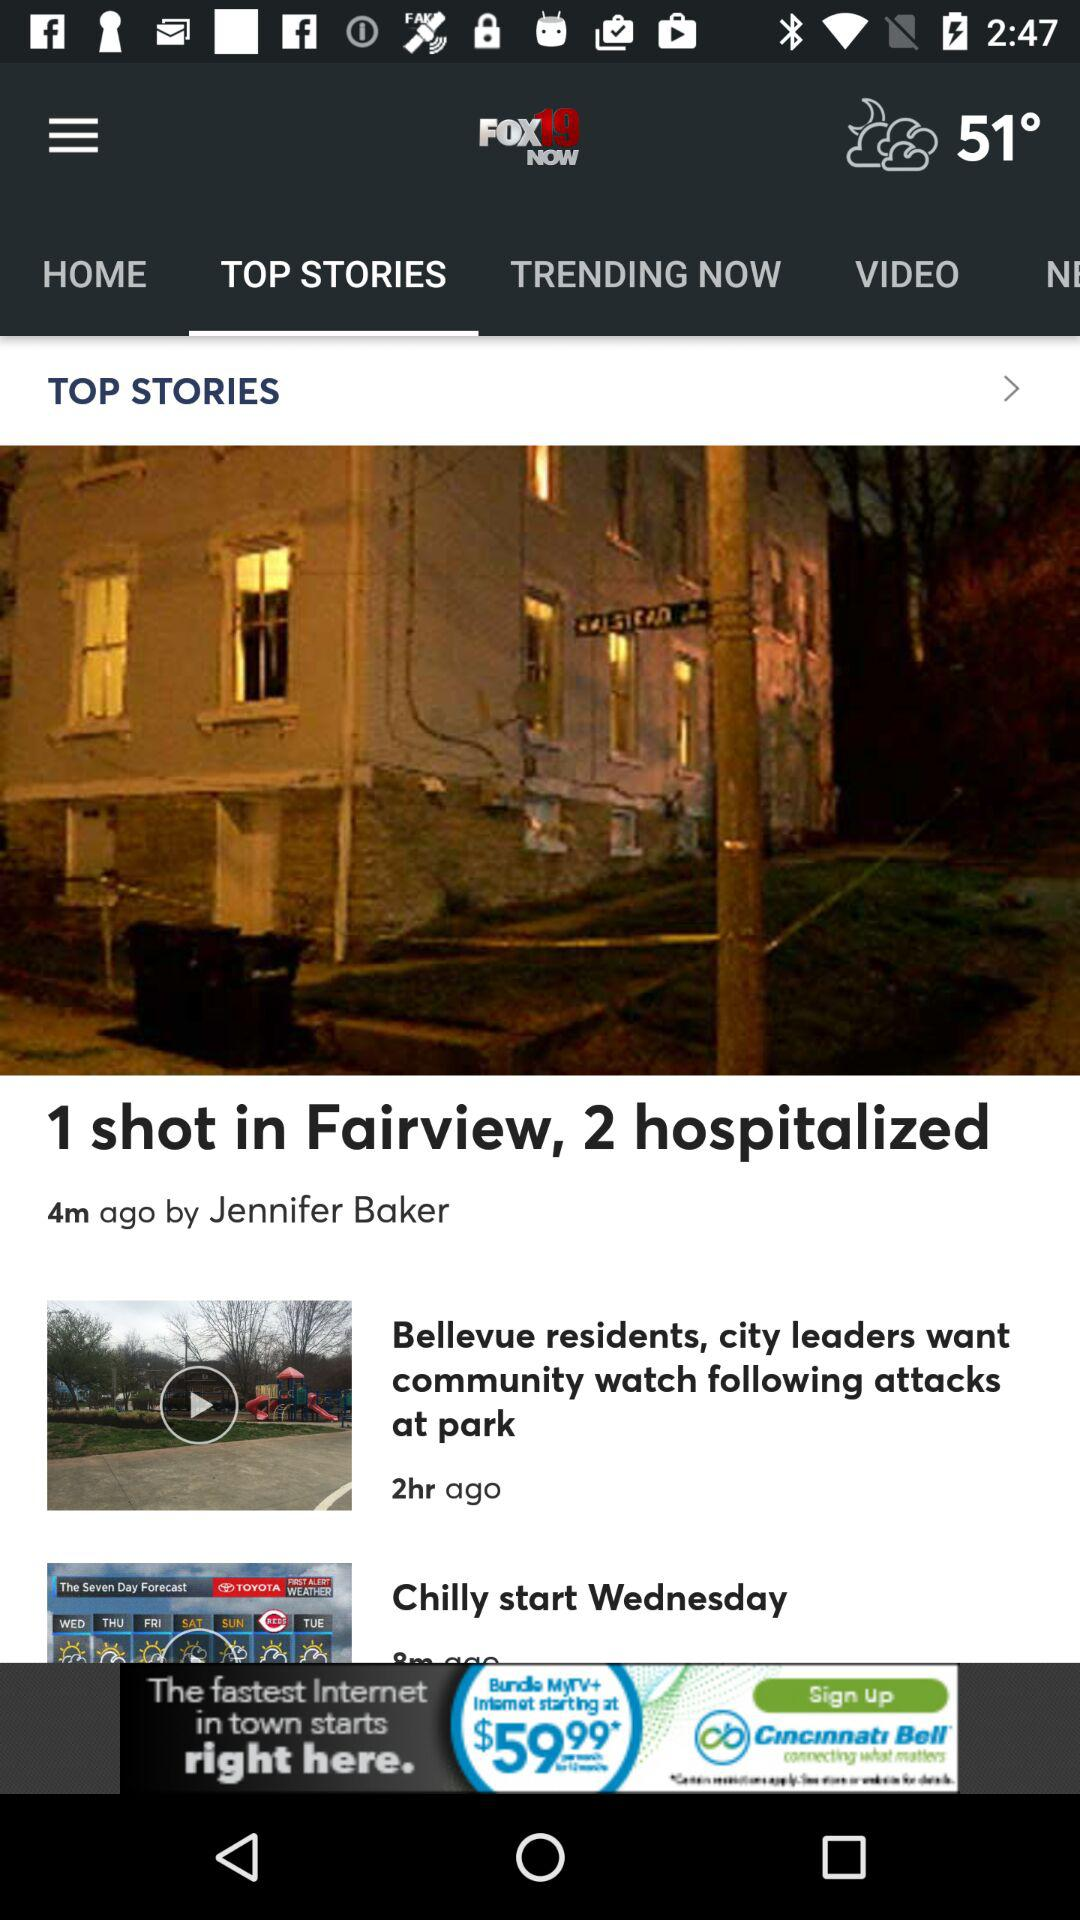How long ago was the "1 shot in Fairview, 2 hospitalized" post posted? The "1 shot in Fairview, 2 hospitalized" post was posted 4 minutes ago. 